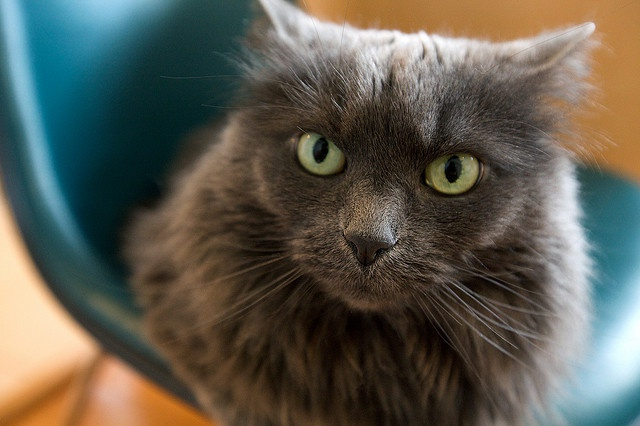Describe the objects in this image and their specific colors. I can see cat in lightblue, black, gray, and maroon tones and chair in lightblue, black, and teal tones in this image. 